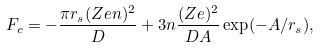Convert formula to latex. <formula><loc_0><loc_0><loc_500><loc_500>F _ { c } = - \frac { \pi r _ { s } ( Z e n ) ^ { 2 } } { D } + 3 n \frac { ( Z e ) ^ { 2 } } { D A } \exp ( - A / r _ { s } ) ,</formula> 